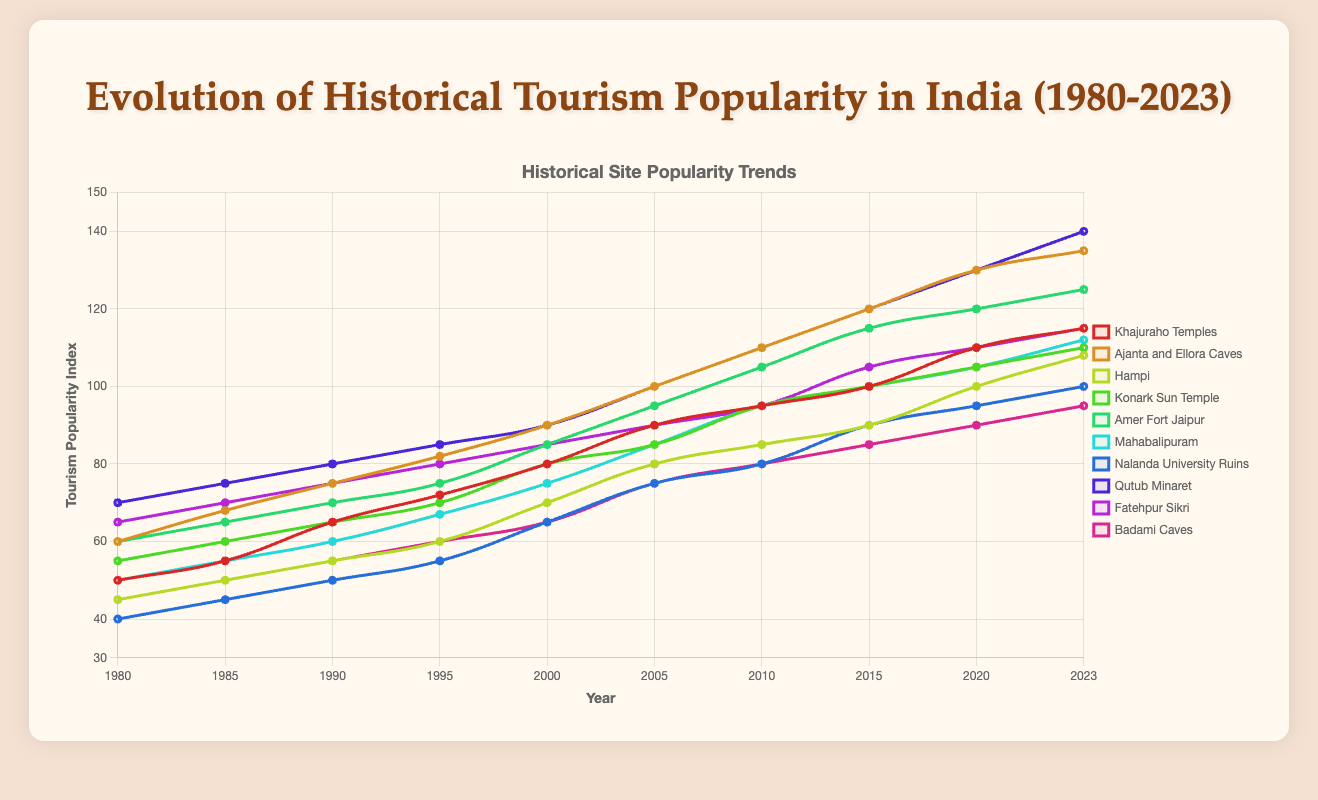What year did the Khajuraho Temples reach an index of 80? By observing the plot, Khajuraho Temples reached an index of 80 in the year 2000.
Answer: 2000 Which site had the highest tourism popularity index in 2020? By comparing the line segments at the year 2020, Qutub Minaret has the highest index of 130.
Answer: Qutub Minaret Which site showed the greatest overall increase in tourism popularity from 1980 to 2023? Calculate the difference between 1980 and 2023 for each site: Qutub Minaret (140-70=70) has the greatest increase.
Answer: Qutub Minaret Between 2005 and 2010, which site experienced the highest increase in the tourism popularity index? Subtract the 2005 values from the 2010 values for each site: Ajanta and Ellora Caves (110-100=10) experienced the highest increase.
Answer: Ajanta and Ellora Caves Which two sites had exactly the same tourism popularity index in 1985? By comparing the data points in 1985, Khajuraho Temples and Mahabalipuram both had an index of 55.
Answer: Khajuraho Temples and Mahabalipuram How much did the tourism popularity index for Nalanda University Ruins change between 1995 and 2015? Calculate the difference between the 1995 and 2015 values: 90 - 55 = 35.
Answer: 35 In which year did Hampi first reach an index above 90? Observing the plot, Hampi reached an index above 90 in the year 2023.
Answer: 2023 Compare Khajuraho Temples' growth from 1980 to 2023 with Konark Sun Temple's growth in the same period. Calculate the difference for both: Khajuraho Temples (115-50=65), Konark Sun Temple (110-55=55). So, Khajuraho Temples had a higher growth of 10.
Answer: Khajuraho Temples: 65, Konark Sun Temple: 55 Between 2010 and 2023, which site had the smallest increase in tourism popularity index? By comparing the changes: Badami Caves (95-80=15) had the smallest increase.
Answer: Badami Caves Rank these sites by their tourism popularity index in 2023 from highest to lowest. List the indexes in 2023 for all sites and sort them: Qutub Minaret (140), Ajanta and Ellora Caves (135), Amer Fort Jaipur (125), Khajuraho Temples (115), Fatehpur Sikri (115), Konark Sun Temple (110), Mahabalipuram (112), Hampi (108), Nalanda University Ruins (100), Badami Caves (95).
Answer: Qutub Minaret, Ajanta and Ellora Caves, Amer Fort Jaipur, Khajuraho Temples, Fatehpur Sikri, Mahabalipuram, Konark Sun Temple, Hampi, Nalanda University Ruins, Badami Caves 